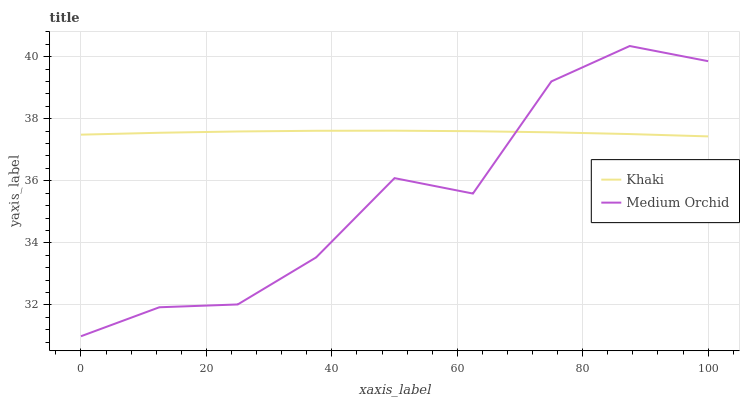Does Medium Orchid have the minimum area under the curve?
Answer yes or no. Yes. Does Khaki have the maximum area under the curve?
Answer yes or no. Yes. Does Khaki have the minimum area under the curve?
Answer yes or no. No. Is Khaki the smoothest?
Answer yes or no. Yes. Is Medium Orchid the roughest?
Answer yes or no. Yes. Is Khaki the roughest?
Answer yes or no. No. Does Medium Orchid have the lowest value?
Answer yes or no. Yes. Does Khaki have the lowest value?
Answer yes or no. No. Does Medium Orchid have the highest value?
Answer yes or no. Yes. Does Khaki have the highest value?
Answer yes or no. No. Does Medium Orchid intersect Khaki?
Answer yes or no. Yes. Is Medium Orchid less than Khaki?
Answer yes or no. No. Is Medium Orchid greater than Khaki?
Answer yes or no. No. 